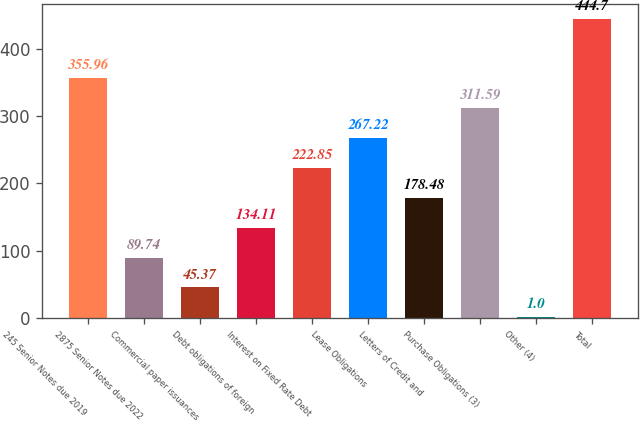Convert chart to OTSL. <chart><loc_0><loc_0><loc_500><loc_500><bar_chart><fcel>245 Senior Notes due 2019<fcel>2875 Senior Notes due 2022<fcel>Commercial paper issuances<fcel>Debt obligations of foreign<fcel>Interest on Fixed Rate Debt<fcel>Lease Obligations<fcel>Letters of Credit and<fcel>Purchase Obligations (3)<fcel>Other (4)<fcel>Total<nl><fcel>355.96<fcel>89.74<fcel>45.37<fcel>134.11<fcel>222.85<fcel>267.22<fcel>178.48<fcel>311.59<fcel>1<fcel>444.7<nl></chart> 